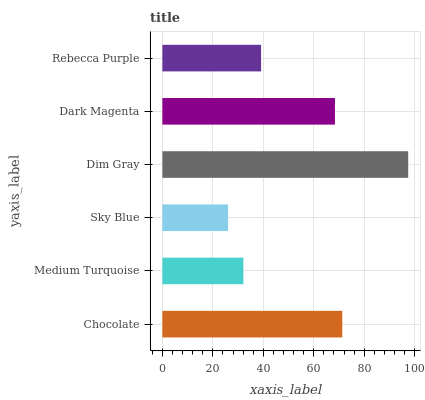Is Sky Blue the minimum?
Answer yes or no. Yes. Is Dim Gray the maximum?
Answer yes or no. Yes. Is Medium Turquoise the minimum?
Answer yes or no. No. Is Medium Turquoise the maximum?
Answer yes or no. No. Is Chocolate greater than Medium Turquoise?
Answer yes or no. Yes. Is Medium Turquoise less than Chocolate?
Answer yes or no. Yes. Is Medium Turquoise greater than Chocolate?
Answer yes or no. No. Is Chocolate less than Medium Turquoise?
Answer yes or no. No. Is Dark Magenta the high median?
Answer yes or no. Yes. Is Rebecca Purple the low median?
Answer yes or no. Yes. Is Medium Turquoise the high median?
Answer yes or no. No. Is Sky Blue the low median?
Answer yes or no. No. 